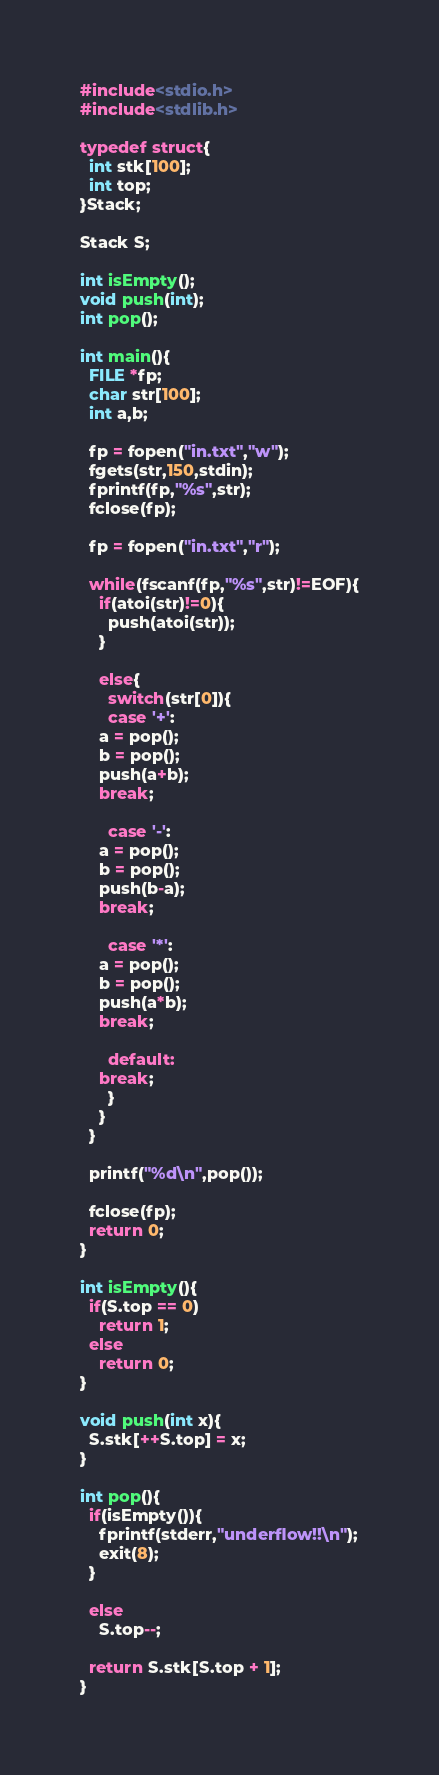Convert code to text. <code><loc_0><loc_0><loc_500><loc_500><_C_>#include<stdio.h>
#include<stdlib.h>

typedef struct{
  int stk[100];
  int top;
}Stack;

Stack S;

int isEmpty();
void push(int);
int pop();

int main(){
  FILE *fp;
  char str[100];
  int a,b;

  fp = fopen("in.txt","w");
  fgets(str,150,stdin);
  fprintf(fp,"%s",str);
  fclose(fp);

  fp = fopen("in.txt","r");
  
  while(fscanf(fp,"%s",str)!=EOF){
    if(atoi(str)!=0){
      push(atoi(str));
    }

    else{
      switch(str[0]){
      case '+':
	a = pop();
	b = pop();
	push(a+b);
	break;
	
      case '-':
	a = pop();
	b = pop();
	push(b-a);
	break;
	
      case '*':
	a = pop();
	b = pop();
	push(a*b);
	break;
	
      default:
	break;
      }
    }
  }

  printf("%d\n",pop());

  fclose(fp);
  return 0;
}

int isEmpty(){
  if(S.top == 0)
    return 1;
  else
    return 0;
}

void push(int x){
  S.stk[++S.top] = x;
}

int pop(){
  if(isEmpty()){
    fprintf(stderr,"underflow!!\n");
    exit(8);
  }

  else
    S.top--;
  
  return S.stk[S.top + 1];
}

</code> 